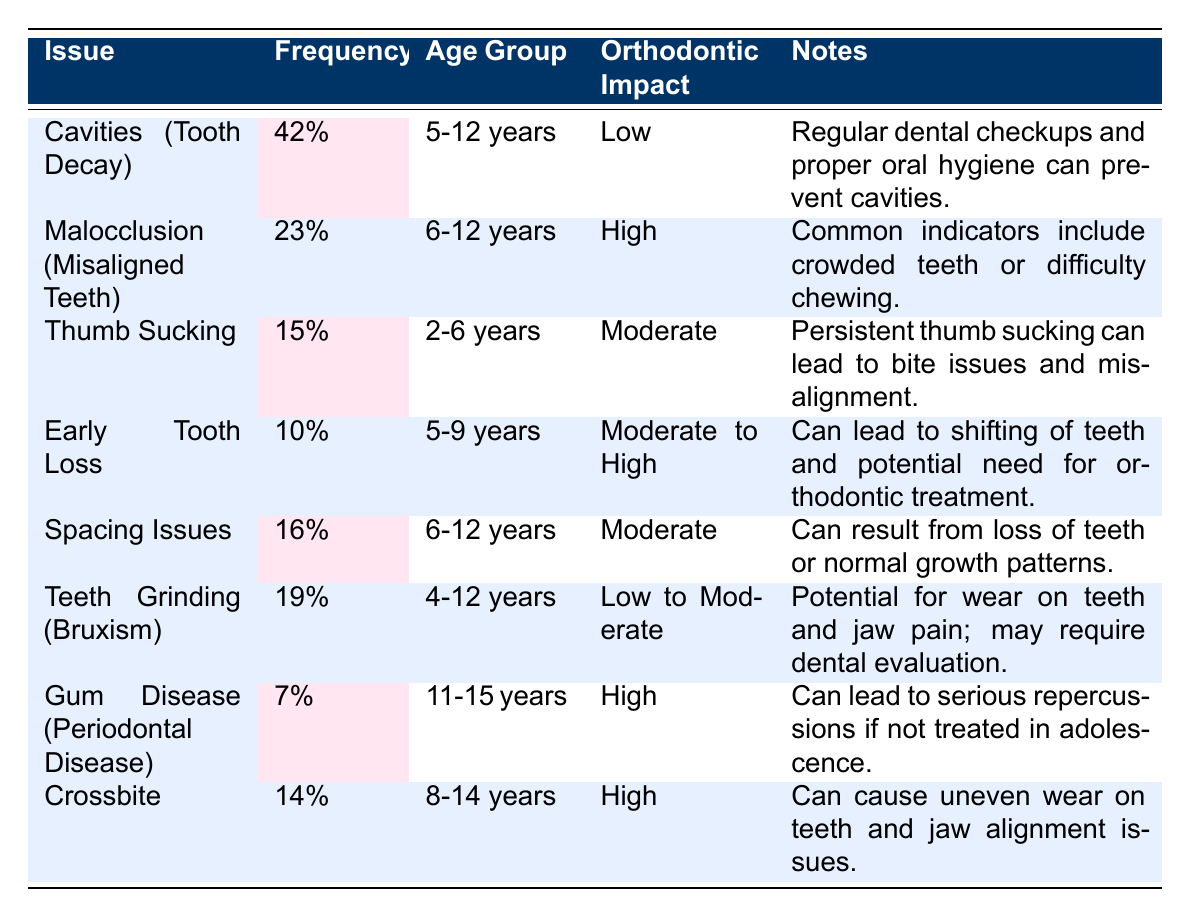What is the frequency of cavities (tooth decay) in children? The table shows that the frequency of cavities (tooth decay) in children is 42%.
Answer: 42% Which dental issue has the highest potential orthodontic impact? The dental issue with the highest potential orthodontic impact is malocclusion (misaligned teeth) with a high impact rating.
Answer: Malocclusion (Misaligned Teeth) How many dental issues have a frequency of 15% or more? The table lists a total of six issues with a frequency of 15% or more: Cavities (42%), Malocclusion (23%), Thumb Sucking (15%), Spacing Issues (16%), Teeth Grinding (19%), and Crossbite (14%).
Answer: Six Is the frequency of gum disease (periodontal disease) higher than that of teeth grinding (bruxism)? Gum disease (periodontal disease) has a frequency of 7%, while teeth grinding (bruxism) has a frequency of 19%. Therefore, the frequency of gum disease is not higher than that of teeth grinding.
Answer: No What is the average frequency of dental issues that have a high potential orthodontic impact? The issues with a high potential orthodontic impact are Malocclusion (23%), Gum Disease (7%), and Crossbite (14%). To find the average, we calculate (23 + 7 + 14) / 3 = 14.67%.
Answer: 14.67% Which age group has the highest frequency of dental issues based on the data provided? The age group of 5-12 years has the highest frequency, as it includes cavities (42%), malocclusion (23%), spacing issues (16%), and early tooth loss (10%). Summing these gives a total of 91%.
Answer: 5-12 years Are spacing issues more common in children aged 6-12 years than early tooth loss in children aged 5-9 years? Spacing issues have a frequency of 16% in the 6-12 years age group, whereas early tooth loss has a frequency of 10% in the 5-9 years age group. Since 16% is greater than 10%, spacing issues are indeed more common.
Answer: Yes What percentage of children experience thumb sucking in the age group of 2-6 years? The table indicates that 15% of children in the age group of 2-6 years experience thumb sucking.
Answer: 15% 